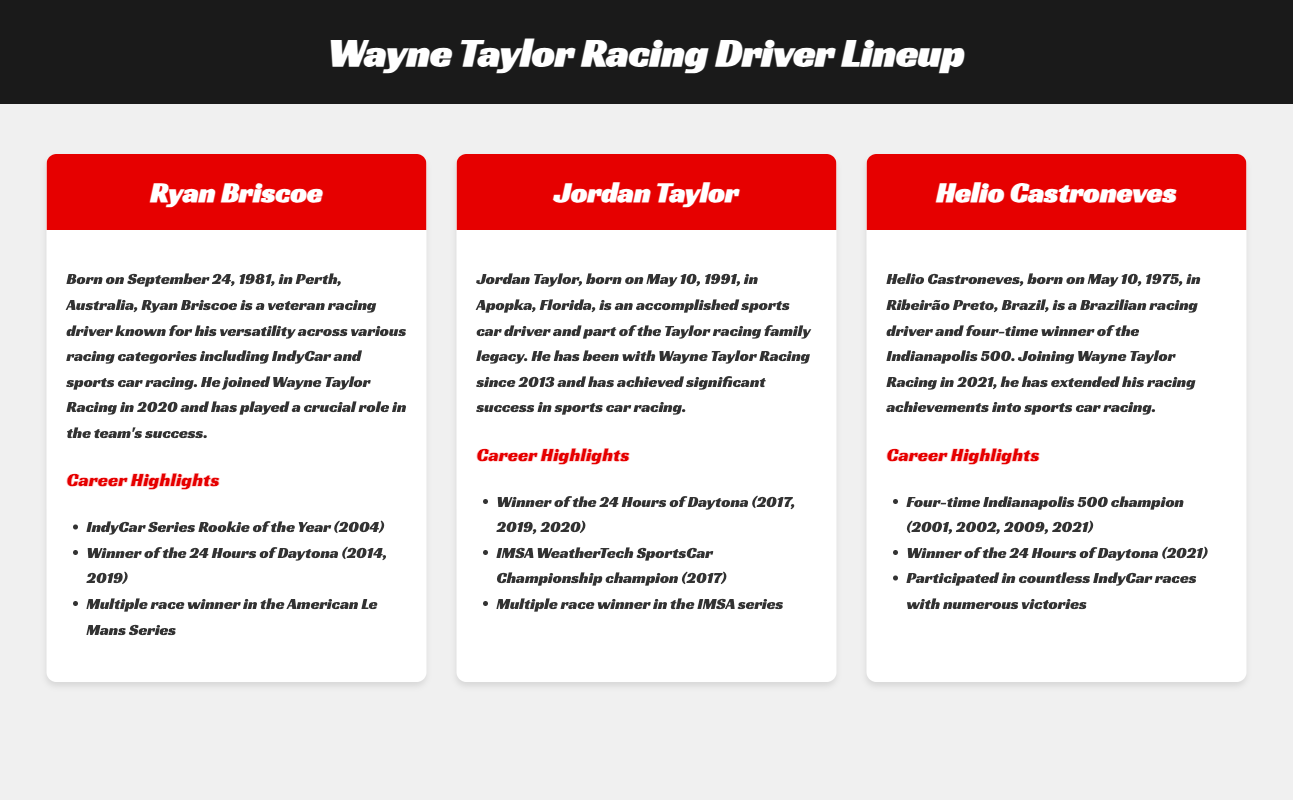What is Ryan Briscoe's date of birth? Ryan Briscoe was born on September 24, 1981.
Answer: September 24, 1981 How many times has Jordan Taylor won the 24 Hours of Daytona? Jordan Taylor won the 24 Hours of Daytona three times: in 2017, 2019, and 2020.
Answer: Three times What is Helio Castroneves known for winning four times? Helio Castroneves is a four-time winner of the Indianapolis 500.
Answer: Indianapolis 500 When did Ryan Briscoe join Wayne Taylor Racing? Ryan Briscoe joined Wayne Taylor Racing in 2020.
Answer: 2020 What major championship did Jordan Taylor win in 2017? Jordan Taylor was the IMSA WeatherTech SportsCar Championship champion in 2017.
Answer: IMSA WeatherTech SportsCar Championship How many career highlights are listed for Helio Castroneves? There are three career highlights listed for Helio Castroneves.
Answer: Three highlights Which driver has a social media link to "JordanTaylor"? The driver with the social media link to "JordanTaylor" is Jordan Taylor.
Answer: Jordan Taylor What is the birthdate of Helio Castroneves? Helio Castroneves was born on May 10, 1975.
Answer: May 10, 1975 